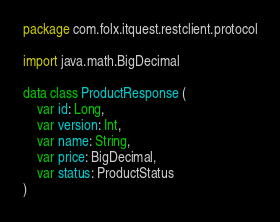Convert code to text. <code><loc_0><loc_0><loc_500><loc_500><_Kotlin_>package com.folx.itquest.restclient.protocol

import java.math.BigDecimal

data class ProductResponse (
    var id: Long,
    var version: Int,
    var name: String,
    var price: BigDecimal,
    var status: ProductStatus
)</code> 